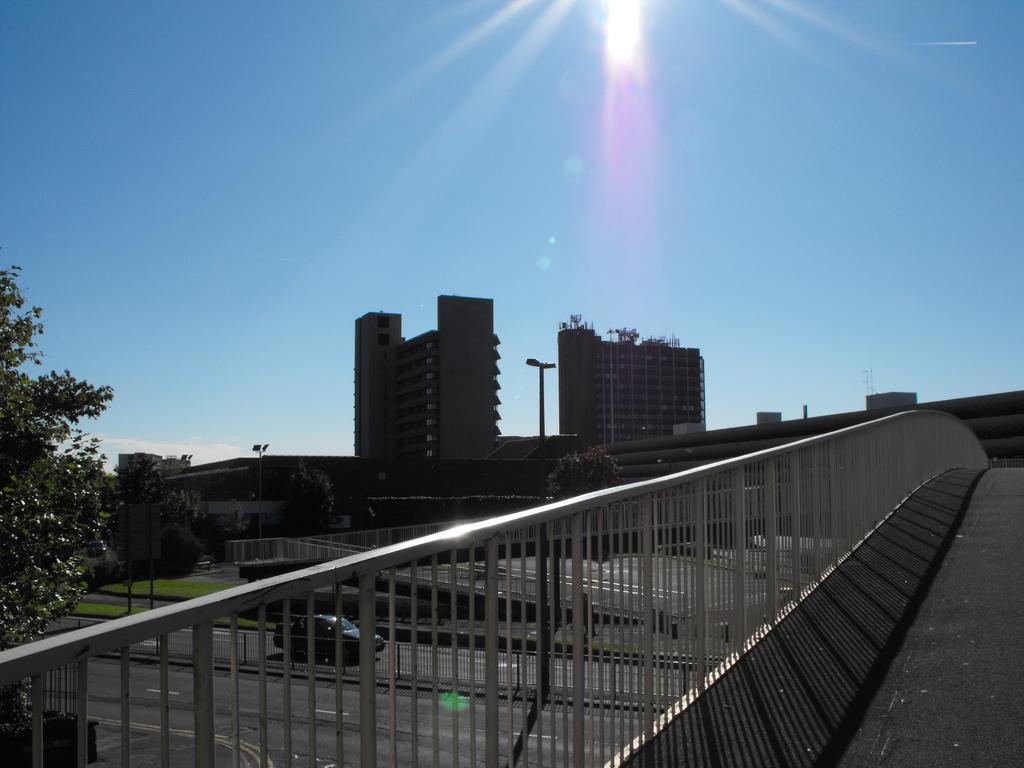In one or two sentences, can you explain what this image depicts? Here there are buildings and trees, this is sky. 